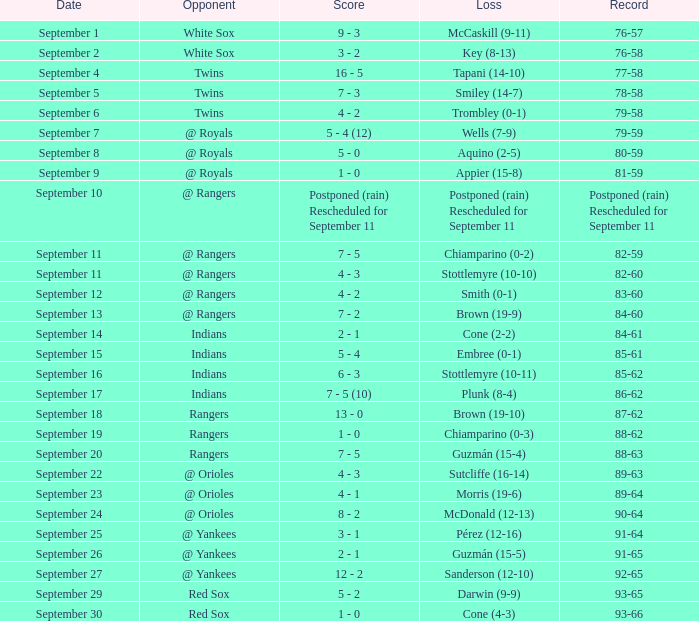On september 15, what was the score of the game with the indians as the opponents? 5 - 4. 